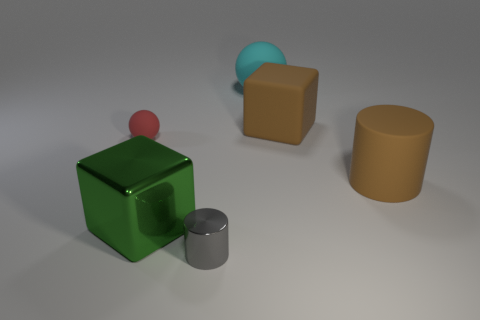Are there any things of the same color as the matte block?
Offer a terse response. Yes. There is a cube that is the same color as the large rubber cylinder; what size is it?
Offer a very short reply. Large. Does the brown block have the same material as the tiny object in front of the matte cylinder?
Ensure brevity in your answer.  No. There is a big thing that is both in front of the large cyan matte thing and behind the small rubber thing; what material is it made of?
Provide a short and direct response. Rubber. There is a cylinder in front of the big brown object in front of the large brown matte cube; what is its color?
Give a very brief answer. Gray. What material is the block that is left of the large cyan sphere?
Provide a short and direct response. Metal. Is the number of big objects less than the number of big matte cylinders?
Provide a short and direct response. No. There is a small gray object; is it the same shape as the green metallic thing to the right of the tiny rubber sphere?
Provide a short and direct response. No. What is the shape of the matte thing that is to the left of the big brown rubber cube and right of the green metallic thing?
Your answer should be very brief. Sphere. Is the number of spheres in front of the tiny metallic thing the same as the number of green blocks in front of the tiny red rubber ball?
Your answer should be very brief. No. 